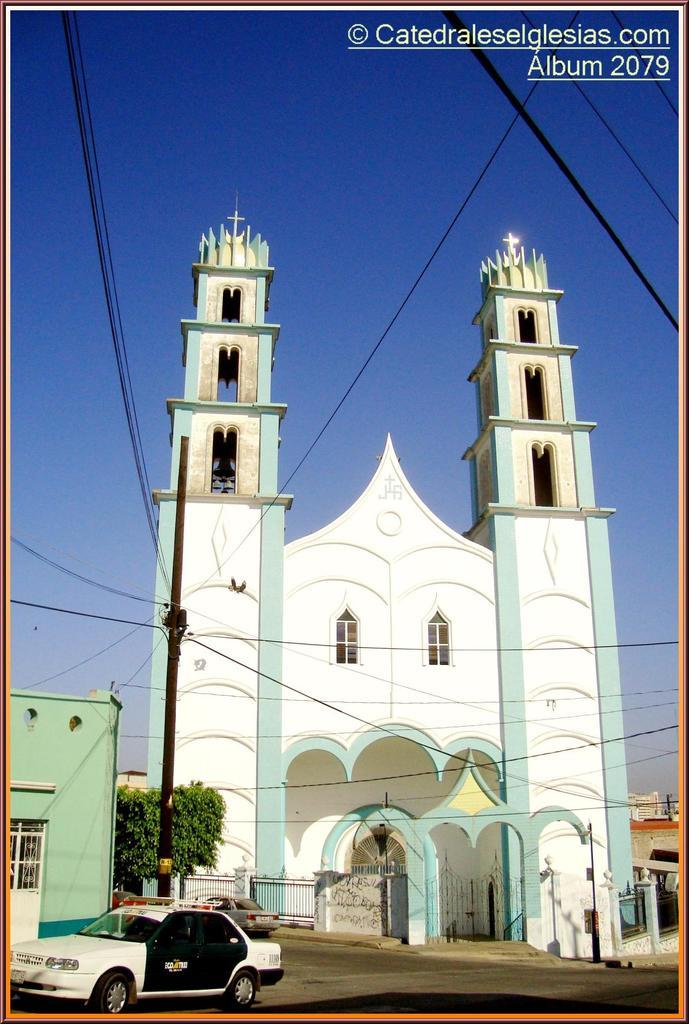<image>
Summarize the visual content of the image. Album 2079 includes an image of a beautiful green and white church. 